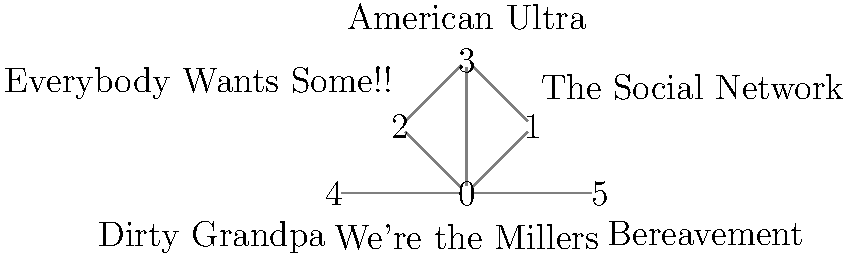In the network graph representing Mark L. Young's film roles, which movie has the highest degree centrality (most connections to other films)? To determine which movie has the highest degree centrality, we need to count the number of connections (edges) for each node in the graph. Let's go through each movie:

1. We're the Millers (node 0): Connected to 5 other movies (nodes 1, 2, 3, 4, and 5)
2. The Social Network (node 1): Connected to 2 other movies (nodes 0 and 3)
3. Everybody Wants Some!! (node 2): Connected to 2 other movies (nodes 0 and 3)
4. American Ultra (node 3): Connected to 3 other movies (nodes 0, 1, and 2)
5. Dirty Grandpa (node 4): Connected to 2 other movies (nodes 0 and 5)
6. Bereavement (node 5): Connected to 2 other movies (nodes 0 and 4)

The movie with the highest number of connections is "We're the Millers" with 5 connections, making it the film with the highest degree centrality in this network of Mark L. Young's roles.
Answer: We're the Millers 